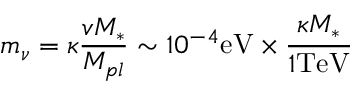<formula> <loc_0><loc_0><loc_500><loc_500>m _ { \nu } = \kappa \frac { v M _ { * } } { M _ { p l } } \sim 1 0 ^ { - 4 } e V \times \frac { \kappa M _ { * } } { 1 T e V }</formula> 